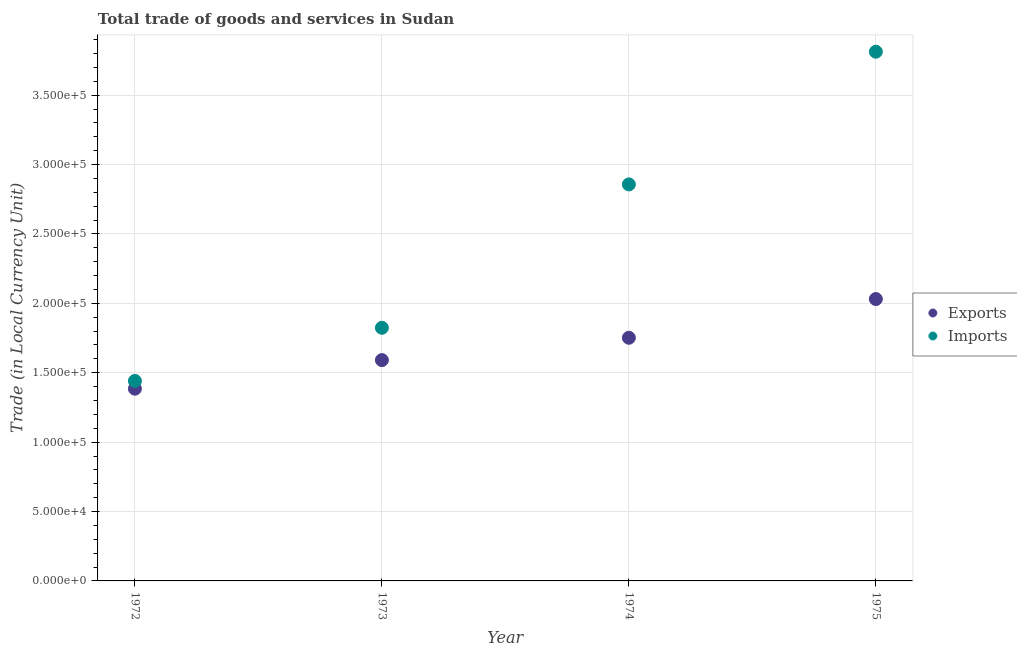Is the number of dotlines equal to the number of legend labels?
Provide a short and direct response. Yes. What is the imports of goods and services in 1974?
Your response must be concise. 2.86e+05. Across all years, what is the maximum imports of goods and services?
Ensure brevity in your answer.  3.81e+05. Across all years, what is the minimum export of goods and services?
Keep it short and to the point. 1.38e+05. In which year was the export of goods and services maximum?
Your response must be concise. 1975. In which year was the imports of goods and services minimum?
Your answer should be compact. 1972. What is the total imports of goods and services in the graph?
Offer a terse response. 9.94e+05. What is the difference between the export of goods and services in 1973 and that in 1974?
Your answer should be compact. -1.61e+04. What is the difference between the export of goods and services in 1975 and the imports of goods and services in 1973?
Offer a terse response. 2.07e+04. What is the average imports of goods and services per year?
Your response must be concise. 2.48e+05. In the year 1975, what is the difference between the export of goods and services and imports of goods and services?
Make the answer very short. -1.78e+05. What is the ratio of the export of goods and services in 1972 to that in 1975?
Ensure brevity in your answer.  0.68. What is the difference between the highest and the second highest imports of goods and services?
Your answer should be very brief. 9.56e+04. What is the difference between the highest and the lowest export of goods and services?
Your answer should be very brief. 6.46e+04. Does the export of goods and services monotonically increase over the years?
Offer a terse response. Yes. Is the imports of goods and services strictly less than the export of goods and services over the years?
Keep it short and to the point. No. What is the difference between two consecutive major ticks on the Y-axis?
Ensure brevity in your answer.  5.00e+04. Does the graph contain grids?
Your answer should be very brief. Yes. Where does the legend appear in the graph?
Your response must be concise. Center right. What is the title of the graph?
Offer a terse response. Total trade of goods and services in Sudan. Does "Old" appear as one of the legend labels in the graph?
Your answer should be very brief. No. What is the label or title of the Y-axis?
Offer a terse response. Trade (in Local Currency Unit). What is the Trade (in Local Currency Unit) of Exports in 1972?
Provide a succinct answer. 1.38e+05. What is the Trade (in Local Currency Unit) of Imports in 1972?
Provide a succinct answer. 1.44e+05. What is the Trade (in Local Currency Unit) in Exports in 1973?
Offer a terse response. 1.59e+05. What is the Trade (in Local Currency Unit) in Imports in 1973?
Provide a succinct answer. 1.82e+05. What is the Trade (in Local Currency Unit) of Exports in 1974?
Offer a very short reply. 1.75e+05. What is the Trade (in Local Currency Unit) of Imports in 1974?
Provide a short and direct response. 2.86e+05. What is the Trade (in Local Currency Unit) in Exports in 1975?
Offer a terse response. 2.03e+05. What is the Trade (in Local Currency Unit) in Imports in 1975?
Provide a short and direct response. 3.81e+05. Across all years, what is the maximum Trade (in Local Currency Unit) in Exports?
Provide a succinct answer. 2.03e+05. Across all years, what is the maximum Trade (in Local Currency Unit) of Imports?
Make the answer very short. 3.81e+05. Across all years, what is the minimum Trade (in Local Currency Unit) of Exports?
Your answer should be very brief. 1.38e+05. Across all years, what is the minimum Trade (in Local Currency Unit) of Imports?
Ensure brevity in your answer.  1.44e+05. What is the total Trade (in Local Currency Unit) in Exports in the graph?
Provide a succinct answer. 6.76e+05. What is the total Trade (in Local Currency Unit) in Imports in the graph?
Your response must be concise. 9.94e+05. What is the difference between the Trade (in Local Currency Unit) of Exports in 1972 and that in 1973?
Make the answer very short. -2.06e+04. What is the difference between the Trade (in Local Currency Unit) in Imports in 1972 and that in 1973?
Offer a very short reply. -3.83e+04. What is the difference between the Trade (in Local Currency Unit) in Exports in 1972 and that in 1974?
Your answer should be compact. -3.67e+04. What is the difference between the Trade (in Local Currency Unit) in Imports in 1972 and that in 1974?
Ensure brevity in your answer.  -1.42e+05. What is the difference between the Trade (in Local Currency Unit) of Exports in 1972 and that in 1975?
Ensure brevity in your answer.  -6.46e+04. What is the difference between the Trade (in Local Currency Unit) in Imports in 1972 and that in 1975?
Offer a very short reply. -2.37e+05. What is the difference between the Trade (in Local Currency Unit) of Exports in 1973 and that in 1974?
Give a very brief answer. -1.61e+04. What is the difference between the Trade (in Local Currency Unit) in Imports in 1973 and that in 1974?
Make the answer very short. -1.03e+05. What is the difference between the Trade (in Local Currency Unit) in Exports in 1973 and that in 1975?
Make the answer very short. -4.40e+04. What is the difference between the Trade (in Local Currency Unit) in Imports in 1973 and that in 1975?
Offer a terse response. -1.99e+05. What is the difference between the Trade (in Local Currency Unit) in Exports in 1974 and that in 1975?
Offer a very short reply. -2.79e+04. What is the difference between the Trade (in Local Currency Unit) in Imports in 1974 and that in 1975?
Your answer should be compact. -9.56e+04. What is the difference between the Trade (in Local Currency Unit) of Exports in 1972 and the Trade (in Local Currency Unit) of Imports in 1973?
Offer a terse response. -4.39e+04. What is the difference between the Trade (in Local Currency Unit) of Exports in 1972 and the Trade (in Local Currency Unit) of Imports in 1974?
Your answer should be compact. -1.47e+05. What is the difference between the Trade (in Local Currency Unit) of Exports in 1972 and the Trade (in Local Currency Unit) of Imports in 1975?
Keep it short and to the point. -2.43e+05. What is the difference between the Trade (in Local Currency Unit) in Exports in 1973 and the Trade (in Local Currency Unit) in Imports in 1974?
Ensure brevity in your answer.  -1.27e+05. What is the difference between the Trade (in Local Currency Unit) of Exports in 1973 and the Trade (in Local Currency Unit) of Imports in 1975?
Your answer should be very brief. -2.22e+05. What is the difference between the Trade (in Local Currency Unit) of Exports in 1974 and the Trade (in Local Currency Unit) of Imports in 1975?
Provide a succinct answer. -2.06e+05. What is the average Trade (in Local Currency Unit) in Exports per year?
Offer a terse response. 1.69e+05. What is the average Trade (in Local Currency Unit) of Imports per year?
Offer a terse response. 2.48e+05. In the year 1972, what is the difference between the Trade (in Local Currency Unit) of Exports and Trade (in Local Currency Unit) of Imports?
Offer a terse response. -5600. In the year 1973, what is the difference between the Trade (in Local Currency Unit) of Exports and Trade (in Local Currency Unit) of Imports?
Keep it short and to the point. -2.33e+04. In the year 1974, what is the difference between the Trade (in Local Currency Unit) in Exports and Trade (in Local Currency Unit) in Imports?
Offer a terse response. -1.10e+05. In the year 1975, what is the difference between the Trade (in Local Currency Unit) of Exports and Trade (in Local Currency Unit) of Imports?
Your answer should be very brief. -1.78e+05. What is the ratio of the Trade (in Local Currency Unit) of Exports in 1972 to that in 1973?
Make the answer very short. 0.87. What is the ratio of the Trade (in Local Currency Unit) in Imports in 1972 to that in 1973?
Your answer should be very brief. 0.79. What is the ratio of the Trade (in Local Currency Unit) of Exports in 1972 to that in 1974?
Provide a short and direct response. 0.79. What is the ratio of the Trade (in Local Currency Unit) in Imports in 1972 to that in 1974?
Offer a terse response. 0.5. What is the ratio of the Trade (in Local Currency Unit) in Exports in 1972 to that in 1975?
Make the answer very short. 0.68. What is the ratio of the Trade (in Local Currency Unit) in Imports in 1972 to that in 1975?
Ensure brevity in your answer.  0.38. What is the ratio of the Trade (in Local Currency Unit) of Exports in 1973 to that in 1974?
Your response must be concise. 0.91. What is the ratio of the Trade (in Local Currency Unit) in Imports in 1973 to that in 1974?
Offer a very short reply. 0.64. What is the ratio of the Trade (in Local Currency Unit) of Exports in 1973 to that in 1975?
Offer a very short reply. 0.78. What is the ratio of the Trade (in Local Currency Unit) in Imports in 1973 to that in 1975?
Offer a very short reply. 0.48. What is the ratio of the Trade (in Local Currency Unit) of Exports in 1974 to that in 1975?
Your answer should be compact. 0.86. What is the ratio of the Trade (in Local Currency Unit) of Imports in 1974 to that in 1975?
Offer a very short reply. 0.75. What is the difference between the highest and the second highest Trade (in Local Currency Unit) in Exports?
Your answer should be compact. 2.79e+04. What is the difference between the highest and the second highest Trade (in Local Currency Unit) in Imports?
Offer a very short reply. 9.56e+04. What is the difference between the highest and the lowest Trade (in Local Currency Unit) in Exports?
Make the answer very short. 6.46e+04. What is the difference between the highest and the lowest Trade (in Local Currency Unit) of Imports?
Keep it short and to the point. 2.37e+05. 